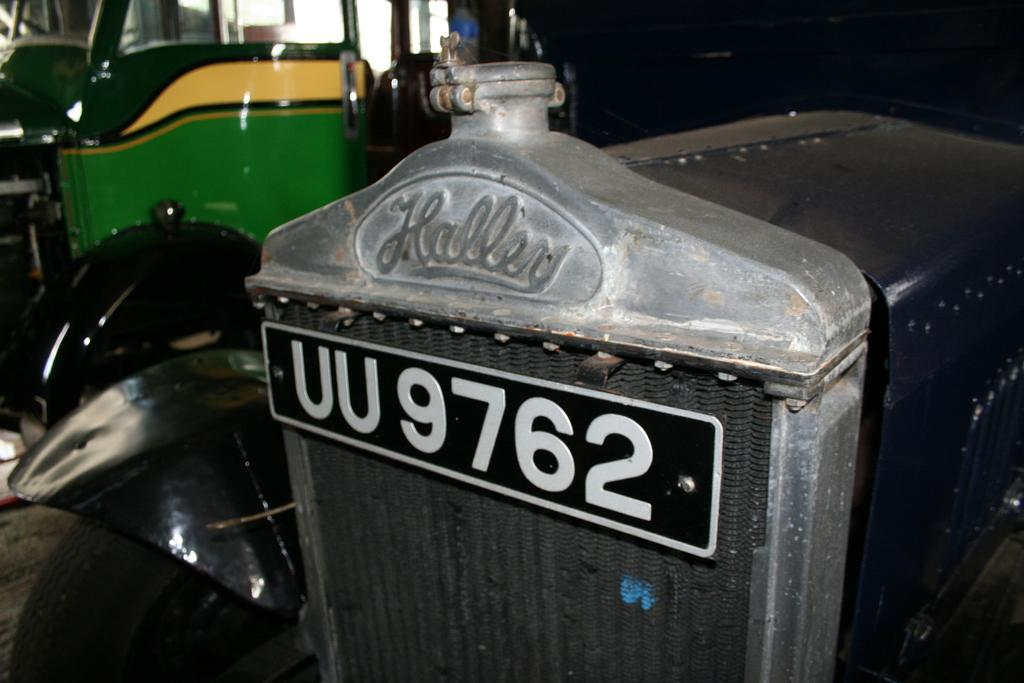What is the main subject of the image? The main subject of the image is a triumph herald. What can be seen on the triumph herald? There is text on the triumph herald. How would you describe the background of the image? The background of the image is blurred. What type of linen is draped over the triumph herald in the image? There is no linen draped over the triumph herald in the image. How does the bomb affect the triumph herald in the image? There is no bomb present in the image, so it cannot affect the triumph herald. 